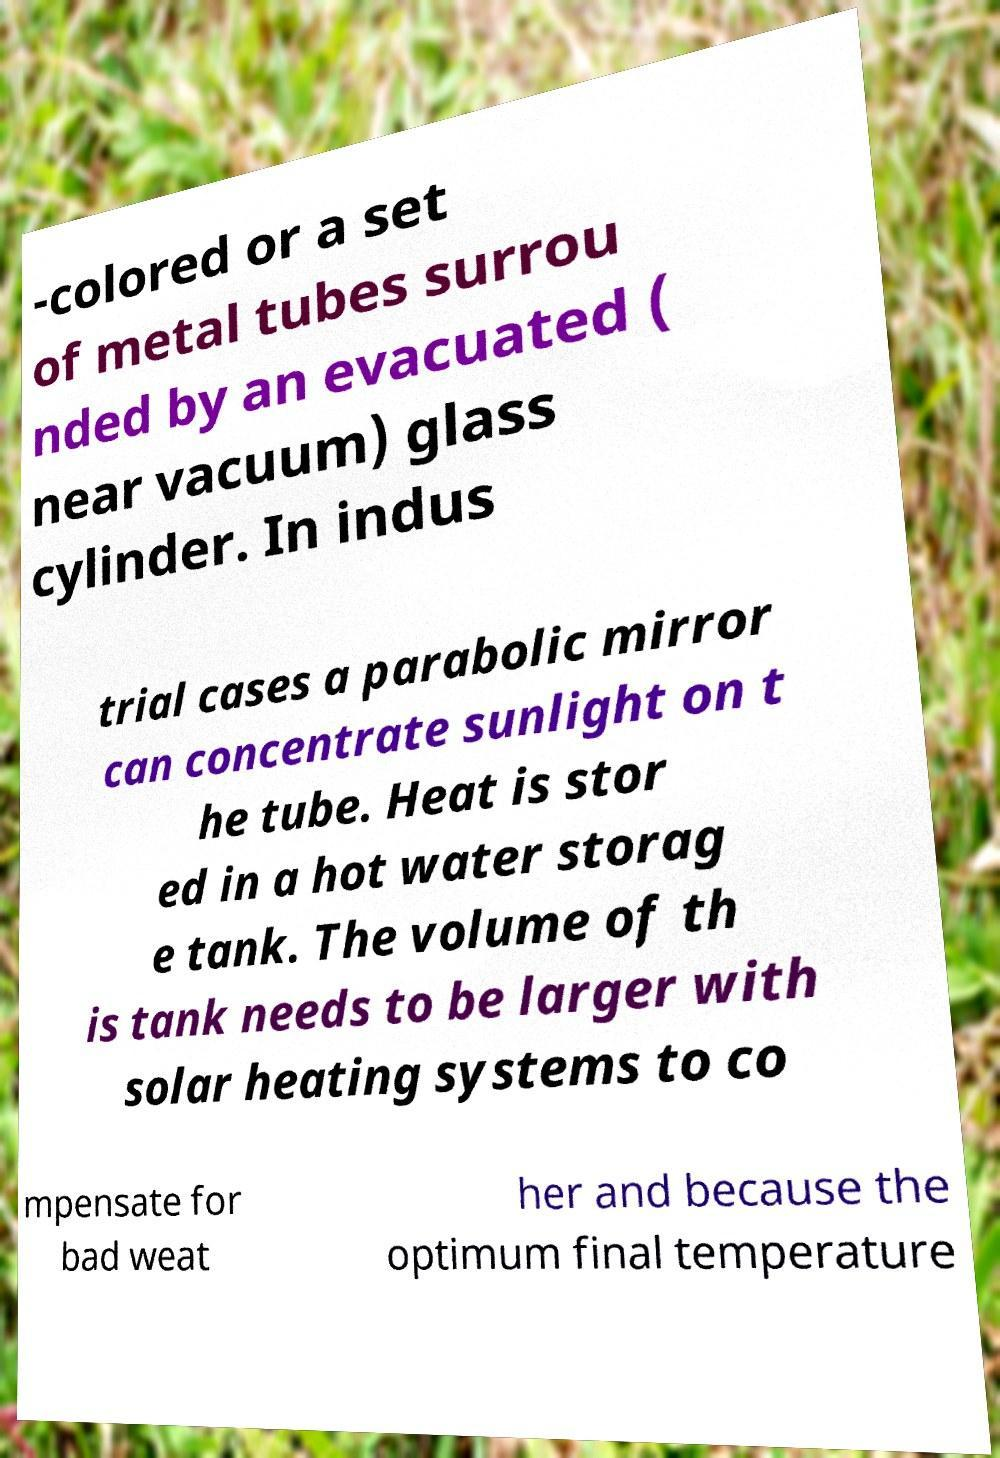Could you extract and type out the text from this image? -colored or a set of metal tubes surrou nded by an evacuated ( near vacuum) glass cylinder. In indus trial cases a parabolic mirror can concentrate sunlight on t he tube. Heat is stor ed in a hot water storag e tank. The volume of th is tank needs to be larger with solar heating systems to co mpensate for bad weat her and because the optimum final temperature 